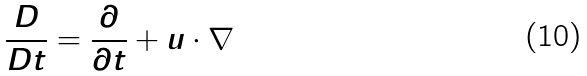<formula> <loc_0><loc_0><loc_500><loc_500>\frac { D } { D t } = \frac { \partial } { \partial t } + u \cdot \nabla</formula> 